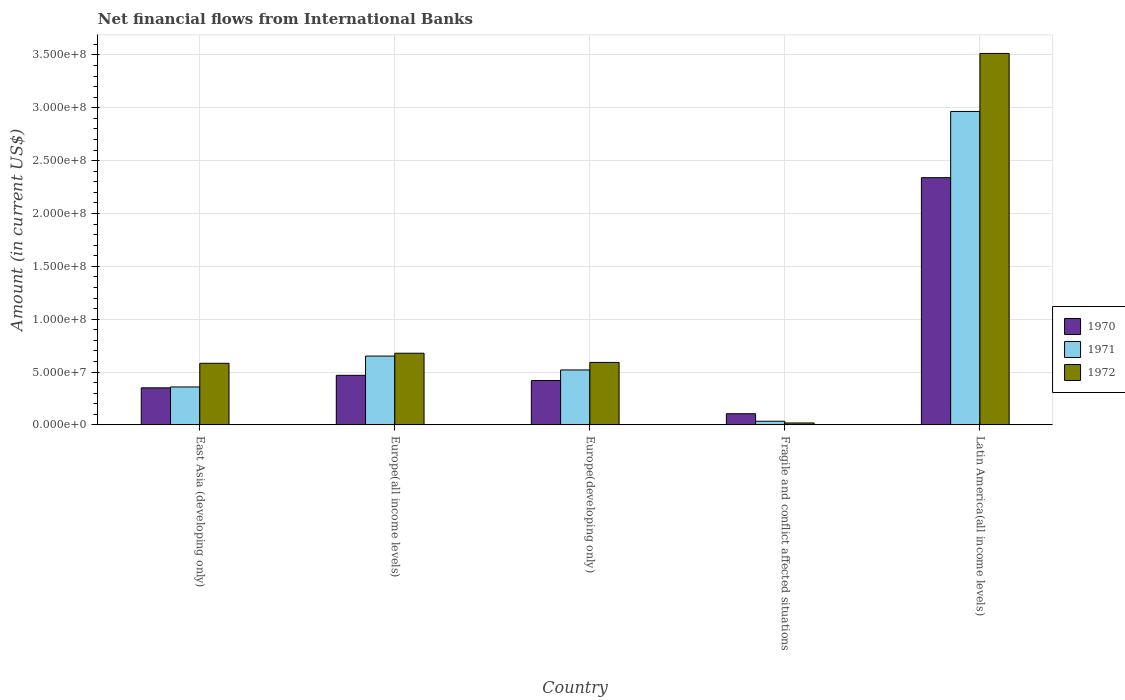How many different coloured bars are there?
Offer a terse response. 3. How many groups of bars are there?
Ensure brevity in your answer.  5. How many bars are there on the 2nd tick from the left?
Your answer should be compact. 3. How many bars are there on the 1st tick from the right?
Make the answer very short. 3. What is the label of the 2nd group of bars from the left?
Make the answer very short. Europe(all income levels). What is the net financial aid flows in 1972 in Europe(developing only)?
Give a very brief answer. 5.91e+07. Across all countries, what is the maximum net financial aid flows in 1970?
Offer a terse response. 2.34e+08. Across all countries, what is the minimum net financial aid flows in 1970?
Make the answer very short. 1.06e+07. In which country was the net financial aid flows in 1971 maximum?
Offer a very short reply. Latin America(all income levels). In which country was the net financial aid flows in 1970 minimum?
Your answer should be compact. Fragile and conflict affected situations. What is the total net financial aid flows in 1972 in the graph?
Your answer should be very brief. 5.38e+08. What is the difference between the net financial aid flows in 1972 in Fragile and conflict affected situations and that in Latin America(all income levels)?
Make the answer very short. -3.49e+08. What is the difference between the net financial aid flows in 1970 in Latin America(all income levels) and the net financial aid flows in 1972 in Fragile and conflict affected situations?
Your answer should be compact. 2.32e+08. What is the average net financial aid flows in 1970 per country?
Make the answer very short. 7.37e+07. What is the difference between the net financial aid flows of/in 1971 and net financial aid flows of/in 1970 in East Asia (developing only)?
Provide a short and direct response. 8.55e+05. In how many countries, is the net financial aid flows in 1972 greater than 50000000 US$?
Offer a terse response. 4. What is the ratio of the net financial aid flows in 1970 in Europe(developing only) to that in Fragile and conflict affected situations?
Your answer should be very brief. 3.97. Is the difference between the net financial aid flows in 1971 in Fragile and conflict affected situations and Latin America(all income levels) greater than the difference between the net financial aid flows in 1970 in Fragile and conflict affected situations and Latin America(all income levels)?
Provide a short and direct response. No. What is the difference between the highest and the second highest net financial aid flows in 1970?
Make the answer very short. 1.87e+08. What is the difference between the highest and the lowest net financial aid flows in 1971?
Provide a succinct answer. 2.93e+08. Is the sum of the net financial aid flows in 1971 in Europe(all income levels) and Fragile and conflict affected situations greater than the maximum net financial aid flows in 1972 across all countries?
Ensure brevity in your answer.  No. What does the 1st bar from the left in Europe(developing only) represents?
Your answer should be compact. 1970. Is it the case that in every country, the sum of the net financial aid flows in 1971 and net financial aid flows in 1970 is greater than the net financial aid flows in 1972?
Offer a terse response. Yes. How many bars are there?
Your answer should be very brief. 15. How many countries are there in the graph?
Keep it short and to the point. 5. Does the graph contain grids?
Offer a very short reply. Yes. How many legend labels are there?
Offer a very short reply. 3. How are the legend labels stacked?
Your answer should be compact. Vertical. What is the title of the graph?
Offer a terse response. Net financial flows from International Banks. What is the label or title of the X-axis?
Your response must be concise. Country. What is the Amount (in current US$) of 1970 in East Asia (developing only)?
Give a very brief answer. 3.51e+07. What is the Amount (in current US$) of 1971 in East Asia (developing only)?
Keep it short and to the point. 3.59e+07. What is the Amount (in current US$) of 1972 in East Asia (developing only)?
Your response must be concise. 5.83e+07. What is the Amount (in current US$) of 1970 in Europe(all income levels)?
Ensure brevity in your answer.  4.69e+07. What is the Amount (in current US$) of 1971 in Europe(all income levels)?
Give a very brief answer. 6.51e+07. What is the Amount (in current US$) of 1972 in Europe(all income levels)?
Give a very brief answer. 6.78e+07. What is the Amount (in current US$) in 1970 in Europe(developing only)?
Provide a succinct answer. 4.20e+07. What is the Amount (in current US$) in 1971 in Europe(developing only)?
Offer a terse response. 5.20e+07. What is the Amount (in current US$) in 1972 in Europe(developing only)?
Your response must be concise. 5.91e+07. What is the Amount (in current US$) of 1970 in Fragile and conflict affected situations?
Give a very brief answer. 1.06e+07. What is the Amount (in current US$) in 1971 in Fragile and conflict affected situations?
Give a very brief answer. 3.47e+06. What is the Amount (in current US$) of 1972 in Fragile and conflict affected situations?
Provide a short and direct response. 1.85e+06. What is the Amount (in current US$) of 1970 in Latin America(all income levels)?
Give a very brief answer. 2.34e+08. What is the Amount (in current US$) of 1971 in Latin America(all income levels)?
Provide a short and direct response. 2.96e+08. What is the Amount (in current US$) of 1972 in Latin America(all income levels)?
Provide a succinct answer. 3.51e+08. Across all countries, what is the maximum Amount (in current US$) in 1970?
Your answer should be very brief. 2.34e+08. Across all countries, what is the maximum Amount (in current US$) in 1971?
Ensure brevity in your answer.  2.96e+08. Across all countries, what is the maximum Amount (in current US$) in 1972?
Ensure brevity in your answer.  3.51e+08. Across all countries, what is the minimum Amount (in current US$) of 1970?
Your response must be concise. 1.06e+07. Across all countries, what is the minimum Amount (in current US$) in 1971?
Your answer should be compact. 3.47e+06. Across all countries, what is the minimum Amount (in current US$) in 1972?
Offer a terse response. 1.85e+06. What is the total Amount (in current US$) of 1970 in the graph?
Give a very brief answer. 3.68e+08. What is the total Amount (in current US$) of 1971 in the graph?
Keep it short and to the point. 4.53e+08. What is the total Amount (in current US$) in 1972 in the graph?
Provide a short and direct response. 5.38e+08. What is the difference between the Amount (in current US$) of 1970 in East Asia (developing only) and that in Europe(all income levels)?
Your answer should be compact. -1.19e+07. What is the difference between the Amount (in current US$) of 1971 in East Asia (developing only) and that in Europe(all income levels)?
Offer a very short reply. -2.92e+07. What is the difference between the Amount (in current US$) in 1972 in East Asia (developing only) and that in Europe(all income levels)?
Provide a short and direct response. -9.52e+06. What is the difference between the Amount (in current US$) in 1970 in East Asia (developing only) and that in Europe(developing only)?
Your answer should be compact. -6.95e+06. What is the difference between the Amount (in current US$) in 1971 in East Asia (developing only) and that in Europe(developing only)?
Ensure brevity in your answer.  -1.61e+07. What is the difference between the Amount (in current US$) in 1972 in East Asia (developing only) and that in Europe(developing only)?
Keep it short and to the point. -8.15e+05. What is the difference between the Amount (in current US$) in 1970 in East Asia (developing only) and that in Fragile and conflict affected situations?
Provide a succinct answer. 2.45e+07. What is the difference between the Amount (in current US$) in 1971 in East Asia (developing only) and that in Fragile and conflict affected situations?
Your answer should be compact. 3.24e+07. What is the difference between the Amount (in current US$) of 1972 in East Asia (developing only) and that in Fragile and conflict affected situations?
Offer a very short reply. 5.64e+07. What is the difference between the Amount (in current US$) of 1970 in East Asia (developing only) and that in Latin America(all income levels)?
Ensure brevity in your answer.  -1.99e+08. What is the difference between the Amount (in current US$) of 1971 in East Asia (developing only) and that in Latin America(all income levels)?
Offer a very short reply. -2.61e+08. What is the difference between the Amount (in current US$) of 1972 in East Asia (developing only) and that in Latin America(all income levels)?
Your answer should be very brief. -2.93e+08. What is the difference between the Amount (in current US$) of 1970 in Europe(all income levels) and that in Europe(developing only)?
Keep it short and to the point. 4.90e+06. What is the difference between the Amount (in current US$) of 1971 in Europe(all income levels) and that in Europe(developing only)?
Provide a succinct answer. 1.31e+07. What is the difference between the Amount (in current US$) in 1972 in Europe(all income levels) and that in Europe(developing only)?
Your response must be concise. 8.70e+06. What is the difference between the Amount (in current US$) in 1970 in Europe(all income levels) and that in Fragile and conflict affected situations?
Ensure brevity in your answer.  3.63e+07. What is the difference between the Amount (in current US$) of 1971 in Europe(all income levels) and that in Fragile and conflict affected situations?
Ensure brevity in your answer.  6.16e+07. What is the difference between the Amount (in current US$) in 1972 in Europe(all income levels) and that in Fragile and conflict affected situations?
Your answer should be very brief. 6.59e+07. What is the difference between the Amount (in current US$) of 1970 in Europe(all income levels) and that in Latin America(all income levels)?
Offer a terse response. -1.87e+08. What is the difference between the Amount (in current US$) in 1971 in Europe(all income levels) and that in Latin America(all income levels)?
Offer a terse response. -2.31e+08. What is the difference between the Amount (in current US$) of 1972 in Europe(all income levels) and that in Latin America(all income levels)?
Your response must be concise. -2.84e+08. What is the difference between the Amount (in current US$) of 1970 in Europe(developing only) and that in Fragile and conflict affected situations?
Make the answer very short. 3.14e+07. What is the difference between the Amount (in current US$) of 1971 in Europe(developing only) and that in Fragile and conflict affected situations?
Your answer should be very brief. 4.85e+07. What is the difference between the Amount (in current US$) in 1972 in Europe(developing only) and that in Fragile and conflict affected situations?
Offer a terse response. 5.72e+07. What is the difference between the Amount (in current US$) in 1970 in Europe(developing only) and that in Latin America(all income levels)?
Give a very brief answer. -1.92e+08. What is the difference between the Amount (in current US$) of 1971 in Europe(developing only) and that in Latin America(all income levels)?
Offer a very short reply. -2.44e+08. What is the difference between the Amount (in current US$) in 1972 in Europe(developing only) and that in Latin America(all income levels)?
Your answer should be very brief. -2.92e+08. What is the difference between the Amount (in current US$) of 1970 in Fragile and conflict affected situations and that in Latin America(all income levels)?
Offer a terse response. -2.23e+08. What is the difference between the Amount (in current US$) in 1971 in Fragile and conflict affected situations and that in Latin America(all income levels)?
Offer a very short reply. -2.93e+08. What is the difference between the Amount (in current US$) of 1972 in Fragile and conflict affected situations and that in Latin America(all income levels)?
Make the answer very short. -3.49e+08. What is the difference between the Amount (in current US$) of 1970 in East Asia (developing only) and the Amount (in current US$) of 1971 in Europe(all income levels)?
Ensure brevity in your answer.  -3.00e+07. What is the difference between the Amount (in current US$) in 1970 in East Asia (developing only) and the Amount (in current US$) in 1972 in Europe(all income levels)?
Keep it short and to the point. -3.27e+07. What is the difference between the Amount (in current US$) of 1971 in East Asia (developing only) and the Amount (in current US$) of 1972 in Europe(all income levels)?
Provide a succinct answer. -3.19e+07. What is the difference between the Amount (in current US$) of 1970 in East Asia (developing only) and the Amount (in current US$) of 1971 in Europe(developing only)?
Offer a terse response. -1.69e+07. What is the difference between the Amount (in current US$) in 1970 in East Asia (developing only) and the Amount (in current US$) in 1972 in Europe(developing only)?
Your answer should be compact. -2.40e+07. What is the difference between the Amount (in current US$) in 1971 in East Asia (developing only) and the Amount (in current US$) in 1972 in Europe(developing only)?
Provide a short and direct response. -2.32e+07. What is the difference between the Amount (in current US$) of 1970 in East Asia (developing only) and the Amount (in current US$) of 1971 in Fragile and conflict affected situations?
Your response must be concise. 3.16e+07. What is the difference between the Amount (in current US$) of 1970 in East Asia (developing only) and the Amount (in current US$) of 1972 in Fragile and conflict affected situations?
Your response must be concise. 3.32e+07. What is the difference between the Amount (in current US$) in 1971 in East Asia (developing only) and the Amount (in current US$) in 1972 in Fragile and conflict affected situations?
Offer a terse response. 3.41e+07. What is the difference between the Amount (in current US$) of 1970 in East Asia (developing only) and the Amount (in current US$) of 1971 in Latin America(all income levels)?
Ensure brevity in your answer.  -2.61e+08. What is the difference between the Amount (in current US$) of 1970 in East Asia (developing only) and the Amount (in current US$) of 1972 in Latin America(all income levels)?
Keep it short and to the point. -3.16e+08. What is the difference between the Amount (in current US$) of 1971 in East Asia (developing only) and the Amount (in current US$) of 1972 in Latin America(all income levels)?
Make the answer very short. -3.15e+08. What is the difference between the Amount (in current US$) in 1970 in Europe(all income levels) and the Amount (in current US$) in 1971 in Europe(developing only)?
Make the answer very short. -5.08e+06. What is the difference between the Amount (in current US$) of 1970 in Europe(all income levels) and the Amount (in current US$) of 1972 in Europe(developing only)?
Ensure brevity in your answer.  -1.22e+07. What is the difference between the Amount (in current US$) of 1971 in Europe(all income levels) and the Amount (in current US$) of 1972 in Europe(developing only)?
Ensure brevity in your answer.  6.00e+06. What is the difference between the Amount (in current US$) in 1970 in Europe(all income levels) and the Amount (in current US$) in 1971 in Fragile and conflict affected situations?
Keep it short and to the point. 4.34e+07. What is the difference between the Amount (in current US$) in 1970 in Europe(all income levels) and the Amount (in current US$) in 1972 in Fragile and conflict affected situations?
Your response must be concise. 4.51e+07. What is the difference between the Amount (in current US$) of 1971 in Europe(all income levels) and the Amount (in current US$) of 1972 in Fragile and conflict affected situations?
Offer a terse response. 6.32e+07. What is the difference between the Amount (in current US$) of 1970 in Europe(all income levels) and the Amount (in current US$) of 1971 in Latin America(all income levels)?
Your answer should be very brief. -2.50e+08. What is the difference between the Amount (in current US$) of 1970 in Europe(all income levels) and the Amount (in current US$) of 1972 in Latin America(all income levels)?
Provide a succinct answer. -3.04e+08. What is the difference between the Amount (in current US$) in 1971 in Europe(all income levels) and the Amount (in current US$) in 1972 in Latin America(all income levels)?
Provide a succinct answer. -2.86e+08. What is the difference between the Amount (in current US$) in 1970 in Europe(developing only) and the Amount (in current US$) in 1971 in Fragile and conflict affected situations?
Your response must be concise. 3.85e+07. What is the difference between the Amount (in current US$) in 1970 in Europe(developing only) and the Amount (in current US$) in 1972 in Fragile and conflict affected situations?
Provide a succinct answer. 4.02e+07. What is the difference between the Amount (in current US$) of 1971 in Europe(developing only) and the Amount (in current US$) of 1972 in Fragile and conflict affected situations?
Your response must be concise. 5.01e+07. What is the difference between the Amount (in current US$) in 1970 in Europe(developing only) and the Amount (in current US$) in 1971 in Latin America(all income levels)?
Offer a terse response. -2.54e+08. What is the difference between the Amount (in current US$) in 1970 in Europe(developing only) and the Amount (in current US$) in 1972 in Latin America(all income levels)?
Your answer should be compact. -3.09e+08. What is the difference between the Amount (in current US$) in 1971 in Europe(developing only) and the Amount (in current US$) in 1972 in Latin America(all income levels)?
Make the answer very short. -2.99e+08. What is the difference between the Amount (in current US$) of 1970 in Fragile and conflict affected situations and the Amount (in current US$) of 1971 in Latin America(all income levels)?
Your answer should be very brief. -2.86e+08. What is the difference between the Amount (in current US$) in 1970 in Fragile and conflict affected situations and the Amount (in current US$) in 1972 in Latin America(all income levels)?
Ensure brevity in your answer.  -3.41e+08. What is the difference between the Amount (in current US$) in 1971 in Fragile and conflict affected situations and the Amount (in current US$) in 1972 in Latin America(all income levels)?
Give a very brief answer. -3.48e+08. What is the average Amount (in current US$) of 1970 per country?
Your answer should be compact. 7.37e+07. What is the average Amount (in current US$) of 1971 per country?
Offer a terse response. 9.06e+07. What is the average Amount (in current US$) in 1972 per country?
Give a very brief answer. 1.08e+08. What is the difference between the Amount (in current US$) of 1970 and Amount (in current US$) of 1971 in East Asia (developing only)?
Keep it short and to the point. -8.55e+05. What is the difference between the Amount (in current US$) of 1970 and Amount (in current US$) of 1972 in East Asia (developing only)?
Provide a short and direct response. -2.32e+07. What is the difference between the Amount (in current US$) in 1971 and Amount (in current US$) in 1972 in East Asia (developing only)?
Your answer should be compact. -2.24e+07. What is the difference between the Amount (in current US$) in 1970 and Amount (in current US$) in 1971 in Europe(all income levels)?
Your response must be concise. -1.82e+07. What is the difference between the Amount (in current US$) of 1970 and Amount (in current US$) of 1972 in Europe(all income levels)?
Your answer should be very brief. -2.09e+07. What is the difference between the Amount (in current US$) of 1971 and Amount (in current US$) of 1972 in Europe(all income levels)?
Keep it short and to the point. -2.70e+06. What is the difference between the Amount (in current US$) in 1970 and Amount (in current US$) in 1971 in Europe(developing only)?
Your response must be concise. -9.98e+06. What is the difference between the Amount (in current US$) of 1970 and Amount (in current US$) of 1972 in Europe(developing only)?
Offer a terse response. -1.71e+07. What is the difference between the Amount (in current US$) in 1971 and Amount (in current US$) in 1972 in Europe(developing only)?
Provide a short and direct response. -7.10e+06. What is the difference between the Amount (in current US$) in 1970 and Amount (in current US$) in 1971 in Fragile and conflict affected situations?
Your answer should be compact. 7.12e+06. What is the difference between the Amount (in current US$) in 1970 and Amount (in current US$) in 1972 in Fragile and conflict affected situations?
Provide a succinct answer. 8.74e+06. What is the difference between the Amount (in current US$) in 1971 and Amount (in current US$) in 1972 in Fragile and conflict affected situations?
Provide a short and direct response. 1.62e+06. What is the difference between the Amount (in current US$) in 1970 and Amount (in current US$) in 1971 in Latin America(all income levels)?
Your answer should be very brief. -6.26e+07. What is the difference between the Amount (in current US$) in 1970 and Amount (in current US$) in 1972 in Latin America(all income levels)?
Your response must be concise. -1.18e+08. What is the difference between the Amount (in current US$) in 1971 and Amount (in current US$) in 1972 in Latin America(all income levels)?
Provide a short and direct response. -5.49e+07. What is the ratio of the Amount (in current US$) in 1970 in East Asia (developing only) to that in Europe(all income levels)?
Make the answer very short. 0.75. What is the ratio of the Amount (in current US$) in 1971 in East Asia (developing only) to that in Europe(all income levels)?
Give a very brief answer. 0.55. What is the ratio of the Amount (in current US$) in 1972 in East Asia (developing only) to that in Europe(all income levels)?
Offer a very short reply. 0.86. What is the ratio of the Amount (in current US$) in 1970 in East Asia (developing only) to that in Europe(developing only)?
Make the answer very short. 0.83. What is the ratio of the Amount (in current US$) of 1971 in East Asia (developing only) to that in Europe(developing only)?
Keep it short and to the point. 0.69. What is the ratio of the Amount (in current US$) of 1972 in East Asia (developing only) to that in Europe(developing only)?
Your answer should be compact. 0.99. What is the ratio of the Amount (in current US$) in 1970 in East Asia (developing only) to that in Fragile and conflict affected situations?
Your answer should be very brief. 3.31. What is the ratio of the Amount (in current US$) of 1971 in East Asia (developing only) to that in Fragile and conflict affected situations?
Give a very brief answer. 10.36. What is the ratio of the Amount (in current US$) of 1972 in East Asia (developing only) to that in Fragile and conflict affected situations?
Ensure brevity in your answer.  31.54. What is the ratio of the Amount (in current US$) in 1970 in East Asia (developing only) to that in Latin America(all income levels)?
Your response must be concise. 0.15. What is the ratio of the Amount (in current US$) of 1971 in East Asia (developing only) to that in Latin America(all income levels)?
Offer a terse response. 0.12. What is the ratio of the Amount (in current US$) in 1972 in East Asia (developing only) to that in Latin America(all income levels)?
Your answer should be very brief. 0.17. What is the ratio of the Amount (in current US$) of 1970 in Europe(all income levels) to that in Europe(developing only)?
Make the answer very short. 1.12. What is the ratio of the Amount (in current US$) in 1971 in Europe(all income levels) to that in Europe(developing only)?
Make the answer very short. 1.25. What is the ratio of the Amount (in current US$) in 1972 in Europe(all income levels) to that in Europe(developing only)?
Provide a succinct answer. 1.15. What is the ratio of the Amount (in current US$) in 1970 in Europe(all income levels) to that in Fragile and conflict affected situations?
Provide a short and direct response. 4.43. What is the ratio of the Amount (in current US$) of 1971 in Europe(all income levels) to that in Fragile and conflict affected situations?
Provide a short and direct response. 18.78. What is the ratio of the Amount (in current US$) of 1972 in Europe(all income levels) to that in Fragile and conflict affected situations?
Provide a short and direct response. 36.69. What is the ratio of the Amount (in current US$) of 1970 in Europe(all income levels) to that in Latin America(all income levels)?
Provide a succinct answer. 0.2. What is the ratio of the Amount (in current US$) in 1971 in Europe(all income levels) to that in Latin America(all income levels)?
Your answer should be compact. 0.22. What is the ratio of the Amount (in current US$) in 1972 in Europe(all income levels) to that in Latin America(all income levels)?
Your answer should be very brief. 0.19. What is the ratio of the Amount (in current US$) of 1970 in Europe(developing only) to that in Fragile and conflict affected situations?
Ensure brevity in your answer.  3.97. What is the ratio of the Amount (in current US$) of 1971 in Europe(developing only) to that in Fragile and conflict affected situations?
Offer a terse response. 15. What is the ratio of the Amount (in current US$) in 1972 in Europe(developing only) to that in Fragile and conflict affected situations?
Make the answer very short. 31.98. What is the ratio of the Amount (in current US$) in 1970 in Europe(developing only) to that in Latin America(all income levels)?
Offer a terse response. 0.18. What is the ratio of the Amount (in current US$) of 1971 in Europe(developing only) to that in Latin America(all income levels)?
Make the answer very short. 0.18. What is the ratio of the Amount (in current US$) in 1972 in Europe(developing only) to that in Latin America(all income levels)?
Your answer should be very brief. 0.17. What is the ratio of the Amount (in current US$) in 1970 in Fragile and conflict affected situations to that in Latin America(all income levels)?
Your answer should be compact. 0.05. What is the ratio of the Amount (in current US$) of 1971 in Fragile and conflict affected situations to that in Latin America(all income levels)?
Your response must be concise. 0.01. What is the ratio of the Amount (in current US$) in 1972 in Fragile and conflict affected situations to that in Latin America(all income levels)?
Your answer should be compact. 0.01. What is the difference between the highest and the second highest Amount (in current US$) in 1970?
Provide a short and direct response. 1.87e+08. What is the difference between the highest and the second highest Amount (in current US$) in 1971?
Your answer should be compact. 2.31e+08. What is the difference between the highest and the second highest Amount (in current US$) of 1972?
Give a very brief answer. 2.84e+08. What is the difference between the highest and the lowest Amount (in current US$) of 1970?
Your response must be concise. 2.23e+08. What is the difference between the highest and the lowest Amount (in current US$) of 1971?
Make the answer very short. 2.93e+08. What is the difference between the highest and the lowest Amount (in current US$) of 1972?
Your answer should be compact. 3.49e+08. 